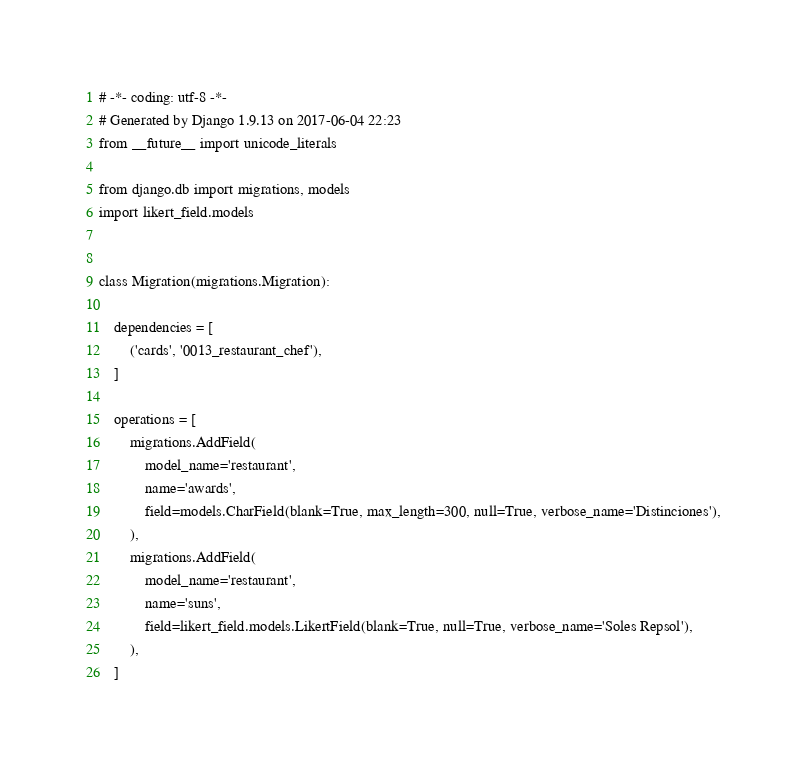<code> <loc_0><loc_0><loc_500><loc_500><_Python_># -*- coding: utf-8 -*-
# Generated by Django 1.9.13 on 2017-06-04 22:23
from __future__ import unicode_literals

from django.db import migrations, models
import likert_field.models


class Migration(migrations.Migration):

    dependencies = [
        ('cards', '0013_restaurant_chef'),
    ]

    operations = [
        migrations.AddField(
            model_name='restaurant',
            name='awards',
            field=models.CharField(blank=True, max_length=300, null=True, verbose_name='Distinciones'),
        ),
        migrations.AddField(
            model_name='restaurant',
            name='suns',
            field=likert_field.models.LikertField(blank=True, null=True, verbose_name='Soles Repsol'),
        ),
    ]
</code> 